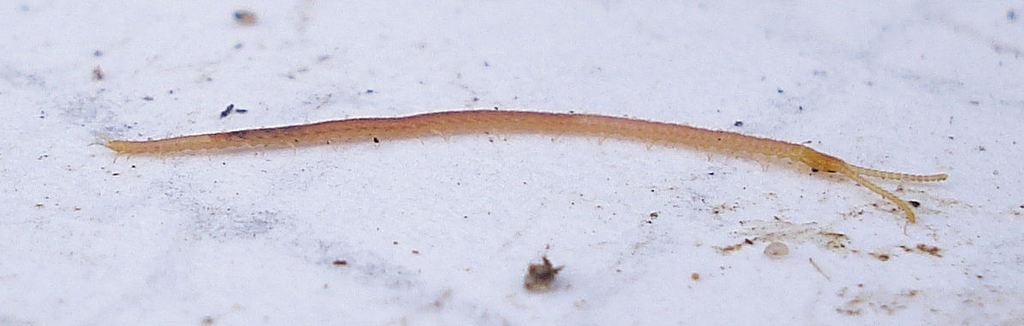What type of creature is present in the image? There is an insect in the image. What is the background or surface that the insect is on? The insect is on a white surface. What type of silk is being discussed by the insect in the image? There is no discussion or silk present in the image; it features an insect on a white surface. 